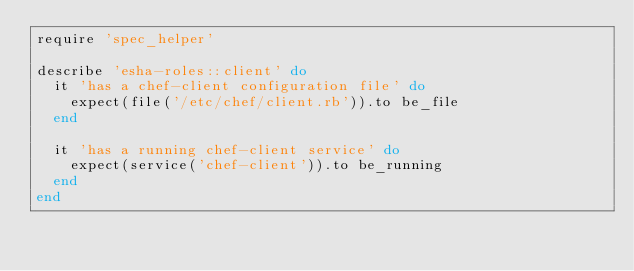<code> <loc_0><loc_0><loc_500><loc_500><_Ruby_>require 'spec_helper'

describe 'esha-roles::client' do
  it 'has a chef-client configuration file' do
    expect(file('/etc/chef/client.rb')).to be_file
  end

  it 'has a running chef-client service' do
    expect(service('chef-client')).to be_running
  end
end
</code> 